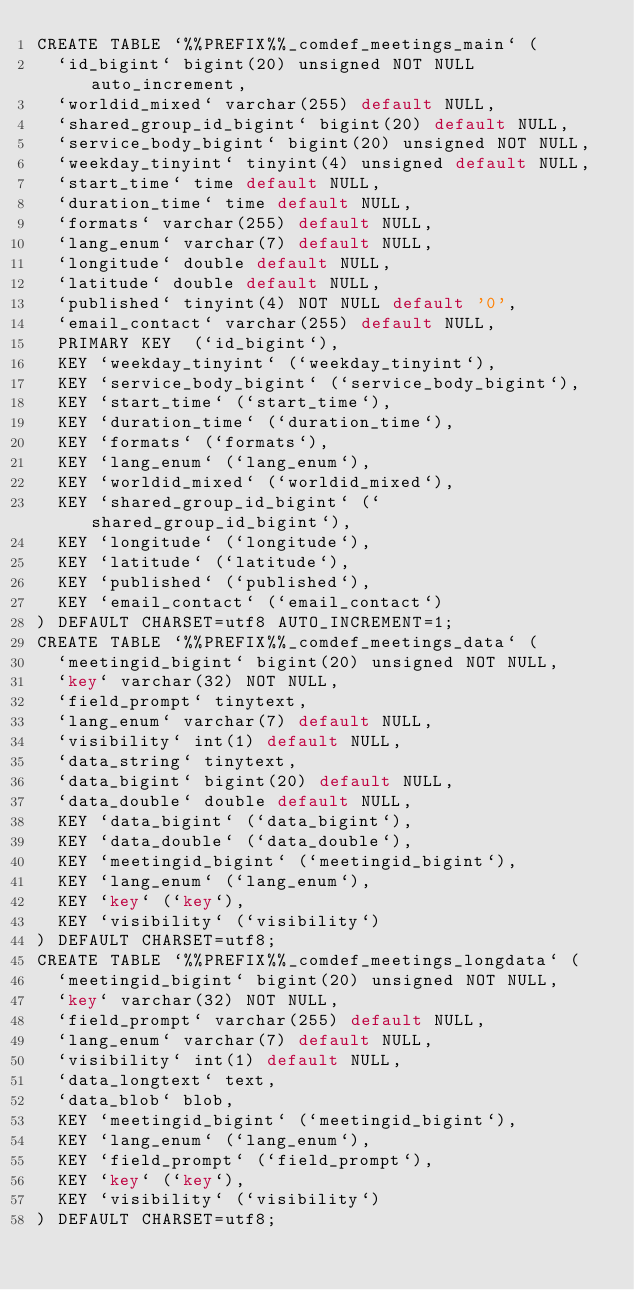Convert code to text. <code><loc_0><loc_0><loc_500><loc_500><_SQL_>CREATE TABLE `%%PREFIX%%_comdef_meetings_main` (
  `id_bigint` bigint(20) unsigned NOT NULL auto_increment,
  `worldid_mixed` varchar(255) default NULL,
  `shared_group_id_bigint` bigint(20) default NULL,
  `service_body_bigint` bigint(20) unsigned NOT NULL,
  `weekday_tinyint` tinyint(4) unsigned default NULL,
  `start_time` time default NULL,
  `duration_time` time default NULL,
  `formats` varchar(255) default NULL,
  `lang_enum` varchar(7) default NULL,
  `longitude` double default NULL,
  `latitude` double default NULL,
  `published` tinyint(4) NOT NULL default '0',
  `email_contact` varchar(255) default NULL,
  PRIMARY KEY  (`id_bigint`),
  KEY `weekday_tinyint` (`weekday_tinyint`),
  KEY `service_body_bigint` (`service_body_bigint`),
  KEY `start_time` (`start_time`),
  KEY `duration_time` (`duration_time`),
  KEY `formats` (`formats`),
  KEY `lang_enum` (`lang_enum`),
  KEY `worldid_mixed` (`worldid_mixed`),
  KEY `shared_group_id_bigint` (`shared_group_id_bigint`),
  KEY `longitude` (`longitude`),
  KEY `latitude` (`latitude`),
  KEY `published` (`published`),
  KEY `email_contact` (`email_contact`)
) DEFAULT CHARSET=utf8 AUTO_INCREMENT=1;
CREATE TABLE `%%PREFIX%%_comdef_meetings_data` (
  `meetingid_bigint` bigint(20) unsigned NOT NULL,
  `key` varchar(32) NOT NULL,
  `field_prompt` tinytext,
  `lang_enum` varchar(7) default NULL,
  `visibility` int(1) default NULL,
  `data_string` tinytext,
  `data_bigint` bigint(20) default NULL,
  `data_double` double default NULL,
  KEY `data_bigint` (`data_bigint`),
  KEY `data_double` (`data_double`),
  KEY `meetingid_bigint` (`meetingid_bigint`),
  KEY `lang_enum` (`lang_enum`),
  KEY `key` (`key`),
  KEY `visibility` (`visibility`)
) DEFAULT CHARSET=utf8;
CREATE TABLE `%%PREFIX%%_comdef_meetings_longdata` (
  `meetingid_bigint` bigint(20) unsigned NOT NULL,
  `key` varchar(32) NOT NULL,
  `field_prompt` varchar(255) default NULL,
  `lang_enum` varchar(7) default NULL,
  `visibility` int(1) default NULL,
  `data_longtext` text,
  `data_blob` blob,
  KEY `meetingid_bigint` (`meetingid_bigint`),
  KEY `lang_enum` (`lang_enum`),
  KEY `field_prompt` (`field_prompt`),
  KEY `key` (`key`),
  KEY `visibility` (`visibility`)
) DEFAULT CHARSET=utf8;
</code> 